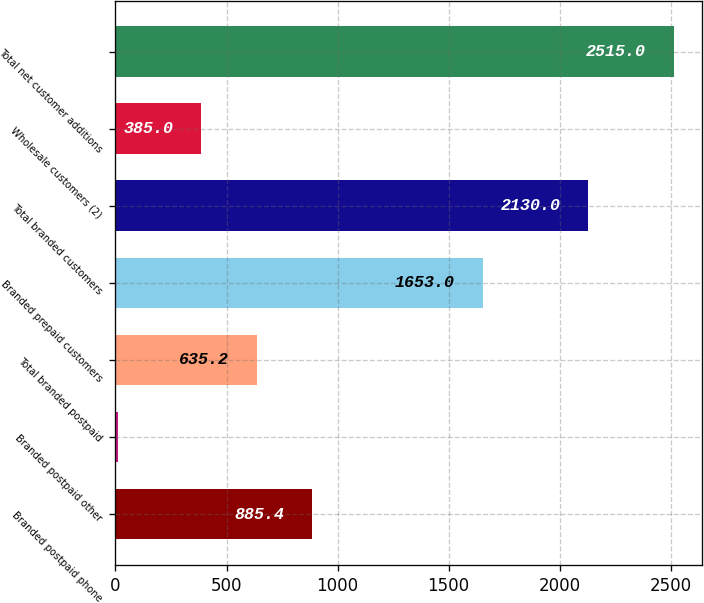Convert chart to OTSL. <chart><loc_0><loc_0><loc_500><loc_500><bar_chart><fcel>Branded postpaid phone<fcel>Branded postpaid other<fcel>Total branded postpaid<fcel>Branded prepaid customers<fcel>Total branded customers<fcel>Wholesale customers (2)<fcel>Total net customer additions<nl><fcel>885.4<fcel>13<fcel>635.2<fcel>1653<fcel>2130<fcel>385<fcel>2515<nl></chart> 